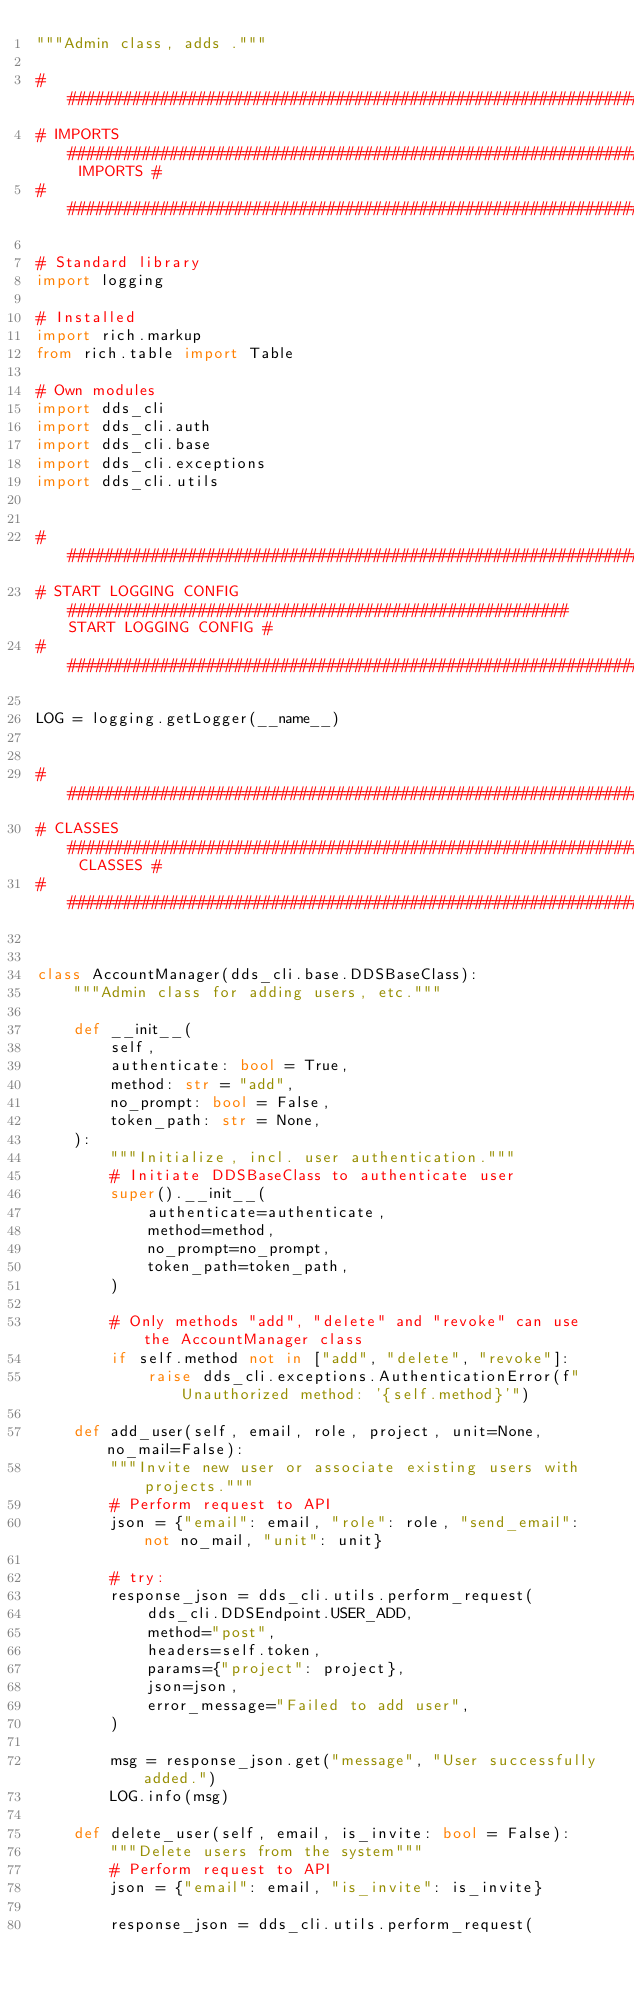Convert code to text. <code><loc_0><loc_0><loc_500><loc_500><_Python_>"""Admin class, adds ."""

####################################################################################################
# IMPORTS ################################################################################ IMPORTS #
###################################################################################################

# Standard library
import logging

# Installed
import rich.markup
from rich.table import Table

# Own modules
import dds_cli
import dds_cli.auth
import dds_cli.base
import dds_cli.exceptions
import dds_cli.utils


####################################################################################################
# START LOGGING CONFIG ###################################################### START LOGGING CONFIG #
####################################################################################################

LOG = logging.getLogger(__name__)


####################################################################################################
# CLASSES ################################################################################ CLASSES #
####################################################################################################


class AccountManager(dds_cli.base.DDSBaseClass):
    """Admin class for adding users, etc."""

    def __init__(
        self,
        authenticate: bool = True,
        method: str = "add",
        no_prompt: bool = False,
        token_path: str = None,
    ):
        """Initialize, incl. user authentication."""
        # Initiate DDSBaseClass to authenticate user
        super().__init__(
            authenticate=authenticate,
            method=method,
            no_prompt=no_prompt,
            token_path=token_path,
        )

        # Only methods "add", "delete" and "revoke" can use the AccountManager class
        if self.method not in ["add", "delete", "revoke"]:
            raise dds_cli.exceptions.AuthenticationError(f"Unauthorized method: '{self.method}'")

    def add_user(self, email, role, project, unit=None, no_mail=False):
        """Invite new user or associate existing users with projects."""
        # Perform request to API
        json = {"email": email, "role": role, "send_email": not no_mail, "unit": unit}

        # try:
        response_json = dds_cli.utils.perform_request(
            dds_cli.DDSEndpoint.USER_ADD,
            method="post",
            headers=self.token,
            params={"project": project},
            json=json,
            error_message="Failed to add user",
        )

        msg = response_json.get("message", "User successfully added.")
        LOG.info(msg)

    def delete_user(self, email, is_invite: bool = False):
        """Delete users from the system"""
        # Perform request to API
        json = {"email": email, "is_invite": is_invite}

        response_json = dds_cli.utils.perform_request(</code> 